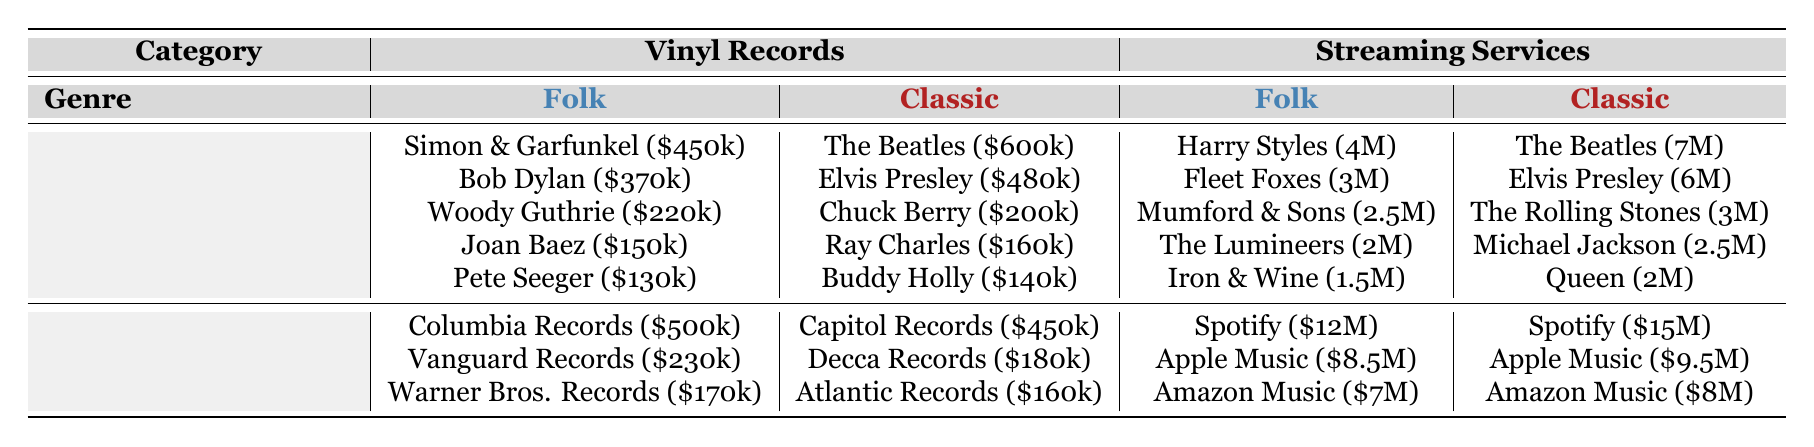What was the total sales revenue for Folk Music vinyl records in 2022? To find the total sales revenue for Folk Music vinyl records, we add the sales from all artists: Simon & Garfunkel ($450,000) + Bob Dylan ($370,000) + Woody Guthrie ($220,000) + Joan Baez ($150,000) + Pete Seeger ($130,000) = $1,420,000.
Answer: 1,420,000 Which platform generated the highest revenue for Classic Music in streaming services? By looking at the revenue for each platform under Classic Music streaming services, Spotify has the highest revenue at $15,000,000, while the others (Apple Music, Amazon Music, Tidal, YouTube Music) have lower revenues. Therefore, Spotify has the highest revenue.
Answer: Spotify Is the total revenue from Folk Music vinyl records greater than that from Classic Music vinyl records? To answer this, calculate the total revenue for both genres. Folk Music: Simon & Garfunkel ($450,000) + Bob Dylan ($370,000) + Woody Guthrie ($220,000) + Joan Baez ($150,000) + Pete Seeger ($130,000) = $1,420,000. Classic Music: The Beatles ($600,000) + Elvis Presley ($480,000) + Chuck Berry ($200,000) + Ray Charles ($160,000) + Buddy Holly ($140,000) = $1,580,000. Since $1,420,000 < $1,580,000, the statement is false.
Answer: No What is the difference in revenue between the top artist in Folk Music and the top artist in Classic Music? The top artist for Folk Music is Simon & Garfunkel with $450,000, and for Classic Music, it's The Beatles with $600,000. The difference is $600,000 - $450,000 = $150,000.
Answer: 150,000 How much did the top three streaming platforms earn for Classic Music combined? The earnings of the top three platforms for Classic Music are: Spotify ($15,000,000), Apple Music ($9,500,000), and Amazon Music ($8,000,000). To find the total, we add these amounts: $15,000,000 + $9,500,000 + $8,000,000 = $32,500,000.
Answer: 32,500,000 Did any Folk Music label generate more revenue than the highest-grossing Classic Music label in vinyl record sales? The highest-grossing label in Classic Music is Capitol Records with $450,000. For Folk Music, Columbia Records earned $500,000, which is greater than $450,000. Therefore, the statement is true.
Answer: Yes 